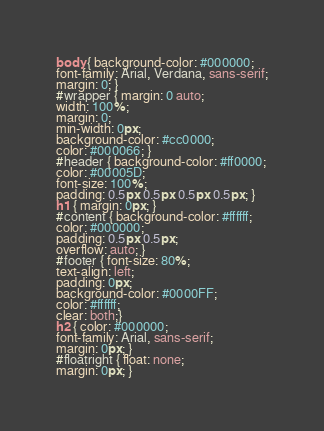Convert code to text. <code><loc_0><loc_0><loc_500><loc_500><_CSS_>body { background-color: #000000;
font-family: Arial, Verdana, sans-serif;
margin: 0; }
#wrapper { margin: 0 auto;
width: 100%;
margin: 0;
min-width: 0px;
background-color: #cc0000;
color: #000066; }
#header { background-color: #ff0000;
color: #00005D;
font-size: 100%;
padding: 0.5px 0.5px 0.5px 0.5px; }
h1 { margin: 0px; }
#content { background-color: #ffffff;
color: #000000;
padding: 0.5px 0.5px;
overflow: auto; }
#footer { font-size: 80%;
text-align: left;
padding: 0px;
background-color: #0000FF;
color: #ffffff;
clear: both;}
h2 { color: #000000;
font-family: Arial, sans-serif;
margin: 0px; }
#floatright { float: none;
margin: 0px; }</code> 